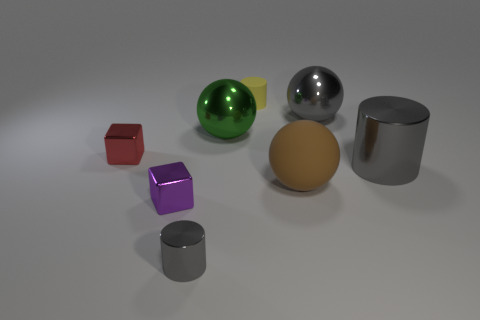There is a small object right of the small gray thing; is its shape the same as the large metal thing that is left of the large brown rubber thing?
Your response must be concise. No. There is a large thing that is the same color as the large shiny cylinder; what is its shape?
Offer a terse response. Sphere. The shiny block in front of the big brown matte sphere that is on the right side of the red metallic cube is what color?
Make the answer very short. Purple. There is another big rubber object that is the same shape as the green object; what color is it?
Give a very brief answer. Brown. What size is the gray thing that is the same shape as the green shiny object?
Your answer should be compact. Large. What is the small cylinder that is in front of the purple block made of?
Your answer should be very brief. Metal. Are there fewer large gray spheres to the right of the big gray shiny sphere than big purple matte cylinders?
Ensure brevity in your answer.  No. There is a tiny shiny object on the left side of the small block that is in front of the tiny red shiny thing; what shape is it?
Your response must be concise. Cube. What color is the big matte ball?
Your answer should be very brief. Brown. How many other objects are the same size as the yellow rubber cylinder?
Your answer should be very brief. 3. 